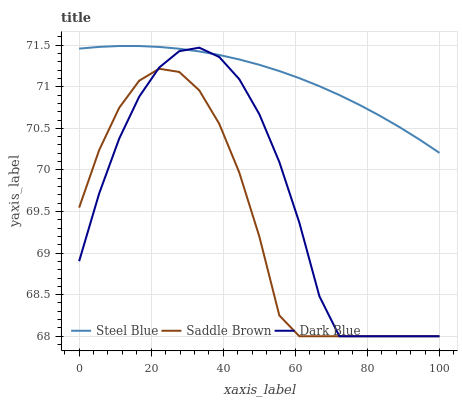Does Saddle Brown have the minimum area under the curve?
Answer yes or no. Yes. Does Steel Blue have the maximum area under the curve?
Answer yes or no. Yes. Does Steel Blue have the minimum area under the curve?
Answer yes or no. No. Does Saddle Brown have the maximum area under the curve?
Answer yes or no. No. Is Steel Blue the smoothest?
Answer yes or no. Yes. Is Saddle Brown the roughest?
Answer yes or no. Yes. Is Saddle Brown the smoothest?
Answer yes or no. No. Is Steel Blue the roughest?
Answer yes or no. No. Does Dark Blue have the lowest value?
Answer yes or no. Yes. Does Steel Blue have the lowest value?
Answer yes or no. No. Does Steel Blue have the highest value?
Answer yes or no. Yes. Does Saddle Brown have the highest value?
Answer yes or no. No. Is Saddle Brown less than Steel Blue?
Answer yes or no. Yes. Is Steel Blue greater than Saddle Brown?
Answer yes or no. Yes. Does Dark Blue intersect Steel Blue?
Answer yes or no. Yes. Is Dark Blue less than Steel Blue?
Answer yes or no. No. Is Dark Blue greater than Steel Blue?
Answer yes or no. No. Does Saddle Brown intersect Steel Blue?
Answer yes or no. No. 